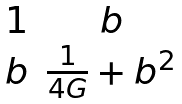Convert formula to latex. <formula><loc_0><loc_0><loc_500><loc_500>\begin{matrix} 1 & b \\ b & \frac { 1 } { 4 G } + b ^ { 2 } \\ \end{matrix}</formula> 